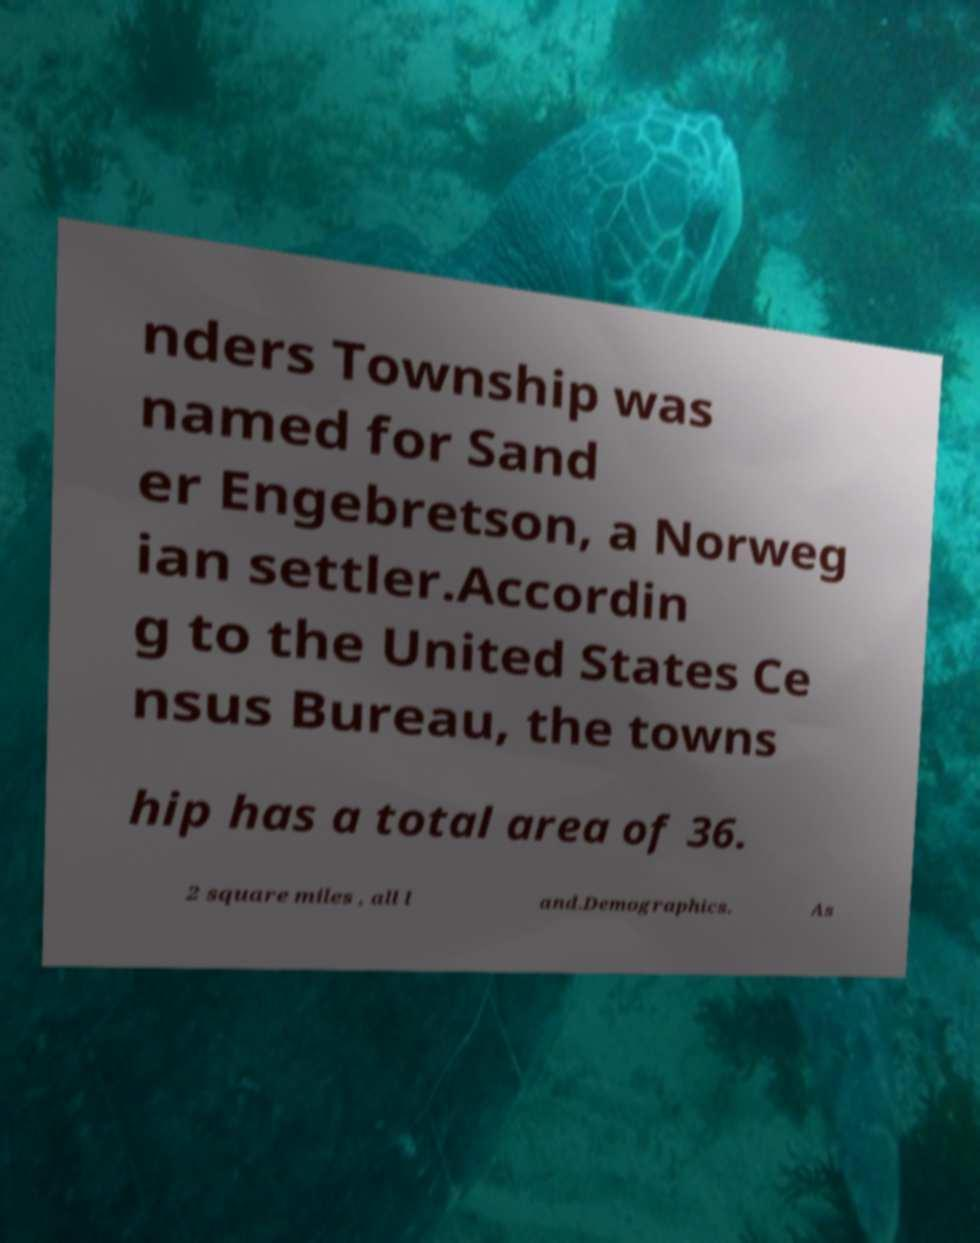Please identify and transcribe the text found in this image. nders Township was named for Sand er Engebretson, a Norweg ian settler.Accordin g to the United States Ce nsus Bureau, the towns hip has a total area of 36. 2 square miles , all l and.Demographics. As 